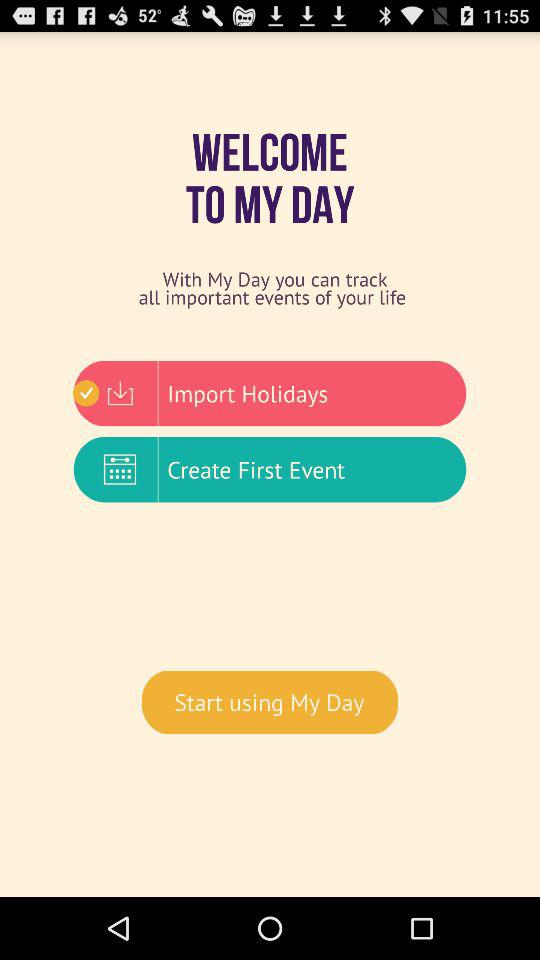Which holidays have been imported?
When the provided information is insufficient, respond with <no answer>. <no answer> 